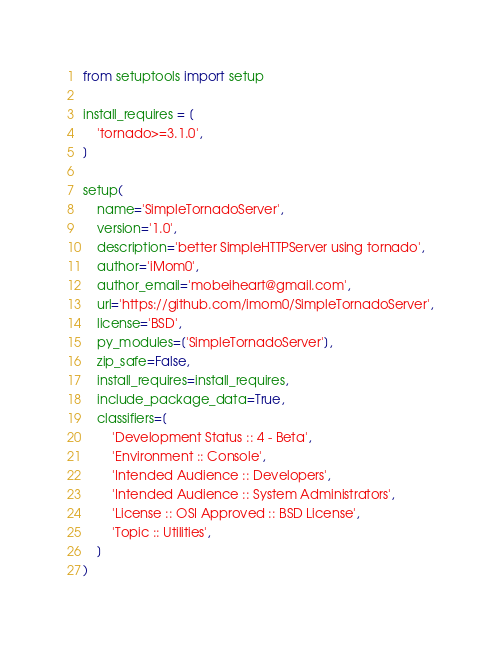<code> <loc_0><loc_0><loc_500><loc_500><_Python_>from setuptools import setup

install_requires = [
    'tornado>=3.1.0',
]

setup(
    name='SimpleTornadoServer',
    version='1.0',
    description='better SimpleHTTPServer using tornado',
    author='iMom0',
    author_email='mobeiheart@gmail.com',
    url='https://github.com/imom0/SimpleTornadoServer',
    license='BSD',
    py_modules=['SimpleTornadoServer'],
    zip_safe=False,
    install_requires=install_requires,
    include_package_data=True,
    classifiers=[
        'Development Status :: 4 - Beta',
        'Environment :: Console',
        'Intended Audience :: Developers',
        'Intended Audience :: System Administrators',
        'License :: OSI Approved :: BSD License',
        'Topic :: Utilities',
    ]
)
</code> 